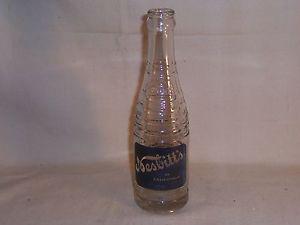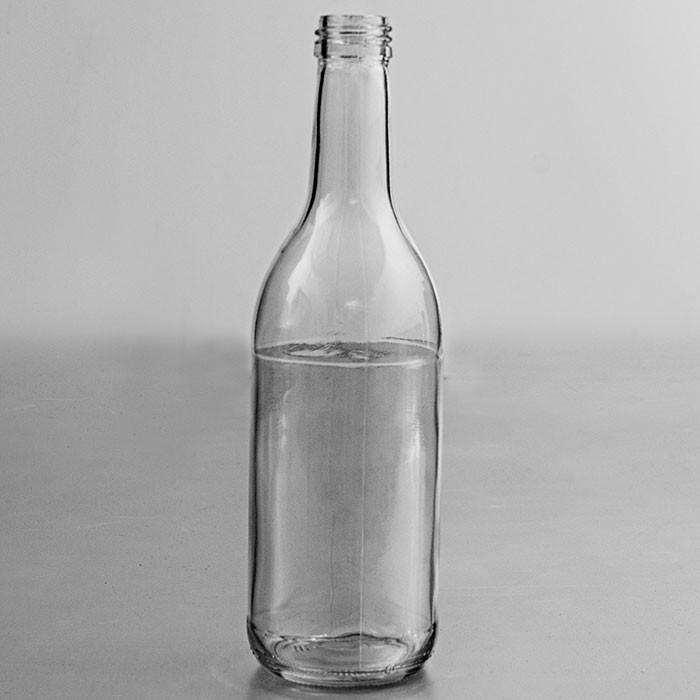The first image is the image on the left, the second image is the image on the right. Considering the images on both sides, is "There are two bottles" valid? Answer yes or no. Yes. The first image is the image on the left, the second image is the image on the right. Analyze the images presented: Is the assertion "The left image contains a single glass bottle with no label on its bottom half, and the right image contains at least three glass bottles with no labels." valid? Answer yes or no. No. 